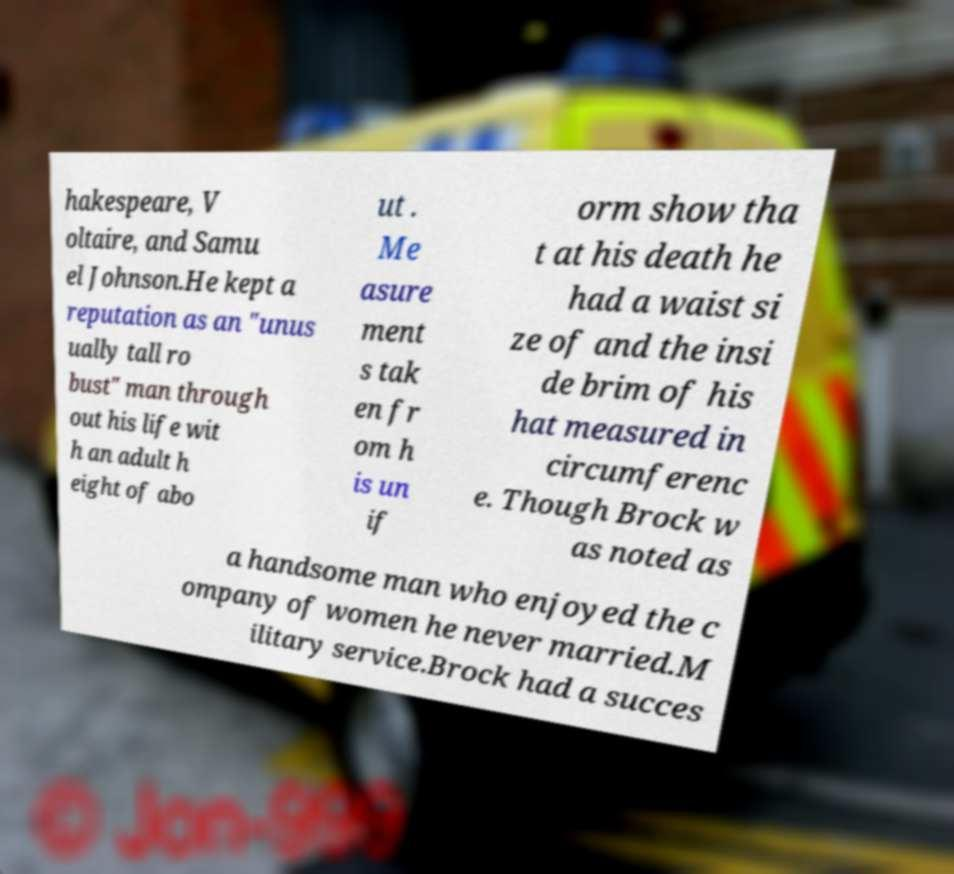What messages or text are displayed in this image? I need them in a readable, typed format. hakespeare, V oltaire, and Samu el Johnson.He kept a reputation as an "unus ually tall ro bust" man through out his life wit h an adult h eight of abo ut . Me asure ment s tak en fr om h is un if orm show tha t at his death he had a waist si ze of and the insi de brim of his hat measured in circumferenc e. Though Brock w as noted as a handsome man who enjoyed the c ompany of women he never married.M ilitary service.Brock had a succes 